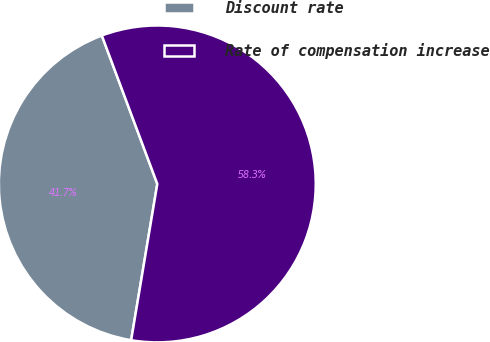Convert chart. <chart><loc_0><loc_0><loc_500><loc_500><pie_chart><fcel>Discount rate<fcel>Rate of compensation increase<nl><fcel>41.67%<fcel>58.33%<nl></chart> 